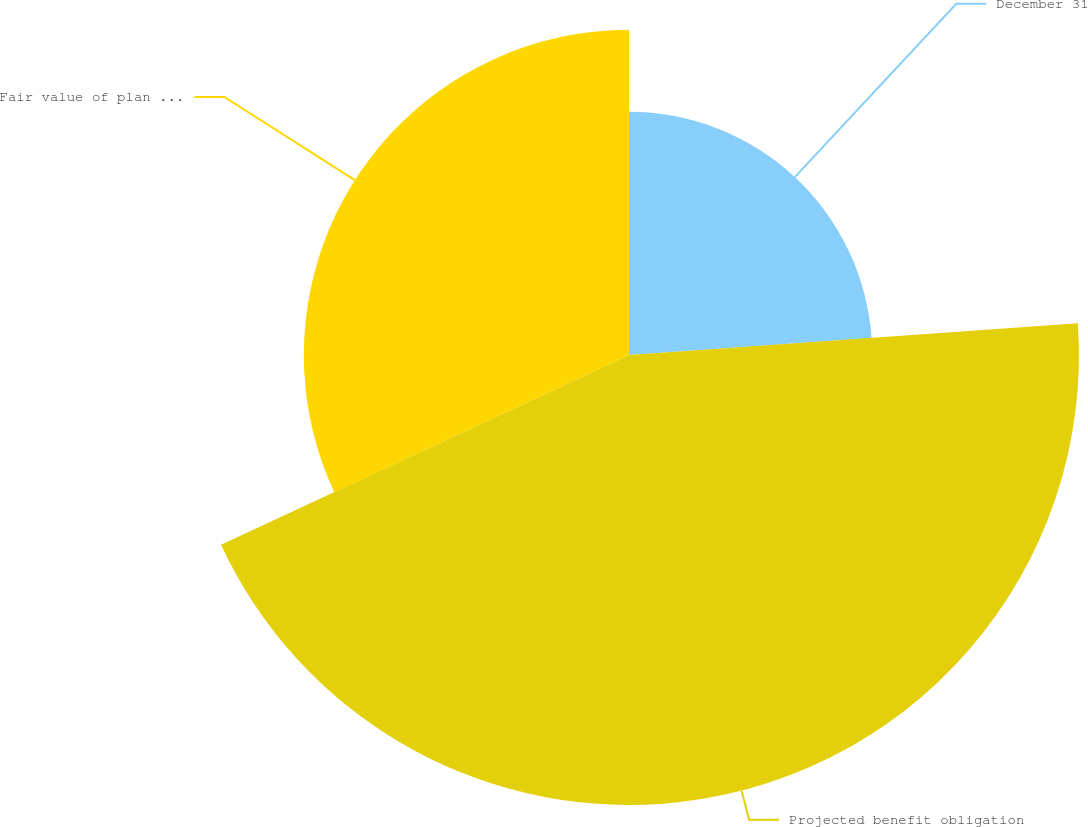<chart> <loc_0><loc_0><loc_500><loc_500><pie_chart><fcel>December 31<fcel>Projected benefit obligation<fcel>Fair value of plan assets<nl><fcel>23.88%<fcel>44.19%<fcel>31.93%<nl></chart> 